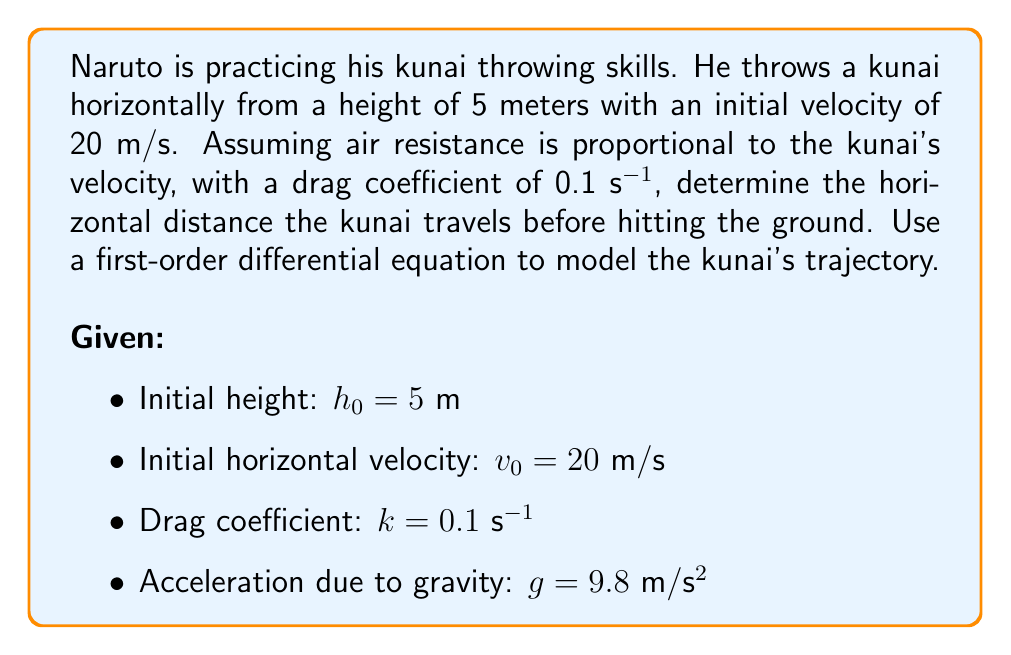Provide a solution to this math problem. Let's approach this problem step-by-step:

1) First, we need to set up our differential equations. We'll have two equations: one for horizontal motion and one for vertical motion.

   Horizontal motion: $\frac{dx}{dt} = v$, where $v$ is the horizontal velocity
   Vertical motion: $\frac{dy}{dt} = -gt$, where $y$ is the vertical position

2) The horizontal velocity is affected by air resistance, which we can model with the following differential equation:

   $\frac{dv}{dt} = -kv$

3) Solving this differential equation:

   $\int \frac{dv}{v} = -k \int dt$
   $\ln|v| = -kt + C$
   $v = Ce^{-kt}$

   At $t=0$, $v = v_0 = 20$, so $C = v_0 = 20$

   Therefore, $v = v_0e^{-kt}$

4) Now we can find the horizontal position $x$ by integrating $v$:

   $x = \int v dt = \int v_0e^{-kt} dt = -\frac{v_0}{k}e^{-kt} + C$

   At $t=0$, $x=0$, so $C = \frac{v_0}{k}$

   Therefore, $x = \frac{v_0}{k}(1 - e^{-kt})$

5) For the vertical motion:

   $y = h_0 - \frac{1}{2}gt^2$

6) The kunai hits the ground when $y = 0$. So we need to solve:

   $0 = 5 - \frac{1}{2}(9.8)t^2$
   $t^2 = \frac{10}{9.8} = 1.0204$
   $t = \sqrt{1.0204} = 1.0102$ seconds

7) Now we can find the horizontal distance by plugging this time into our equation for $x$:

   $x = \frac{20}{0.1}(1 - e^{-0.1(1.0102)})$
   $x = 200(1 - e^{-0.10102})$
   $x = 200(1 - 0.9039)$
   $x = 19.22$ meters
Answer: The kunai travels approximately 19.22 meters horizontally before hitting the ground. 